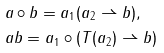Convert formula to latex. <formula><loc_0><loc_0><loc_500><loc_500>& a \circ b = a _ { 1 } ( a _ { 2 } \rightharpoonup b ) , \\ & a b = a _ { 1 } \circ ( T ( a _ { 2 } ) \rightharpoonup b )</formula> 